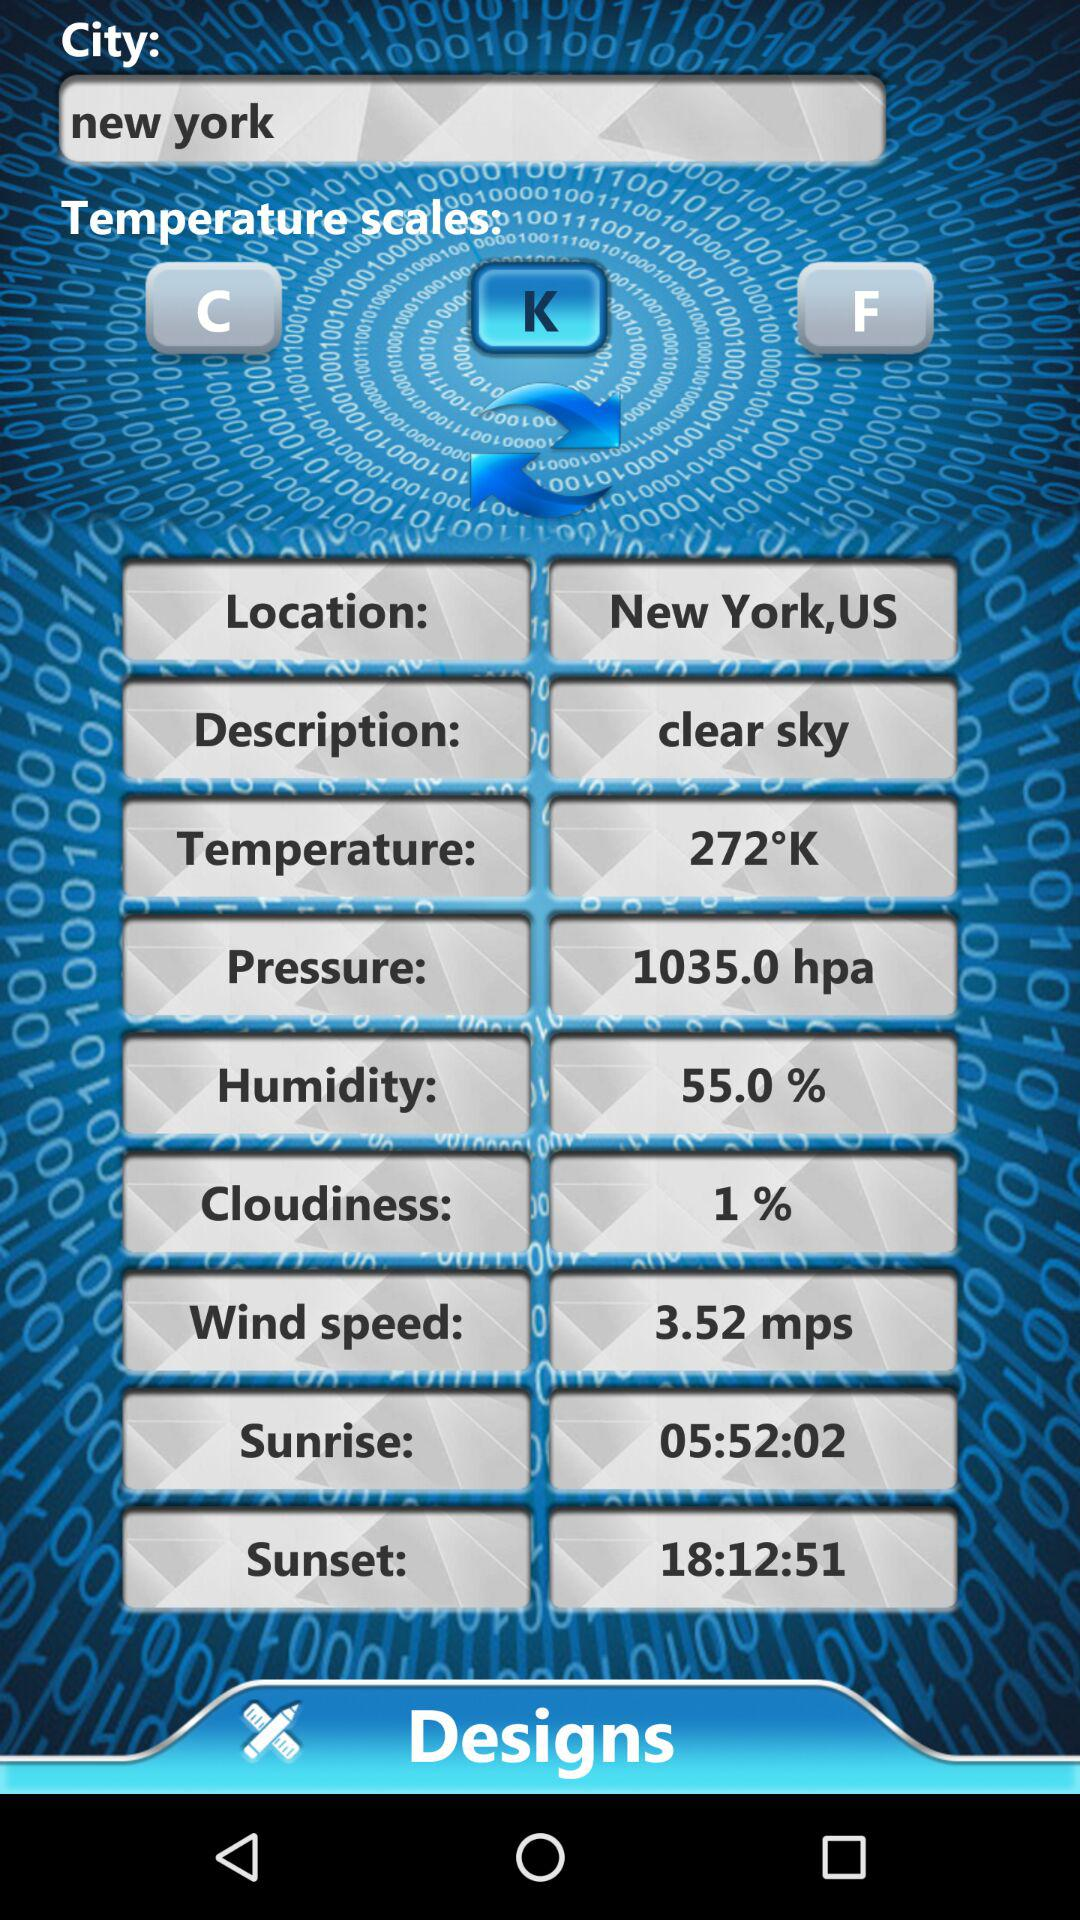What is the humidity? The humidity is 55%. 